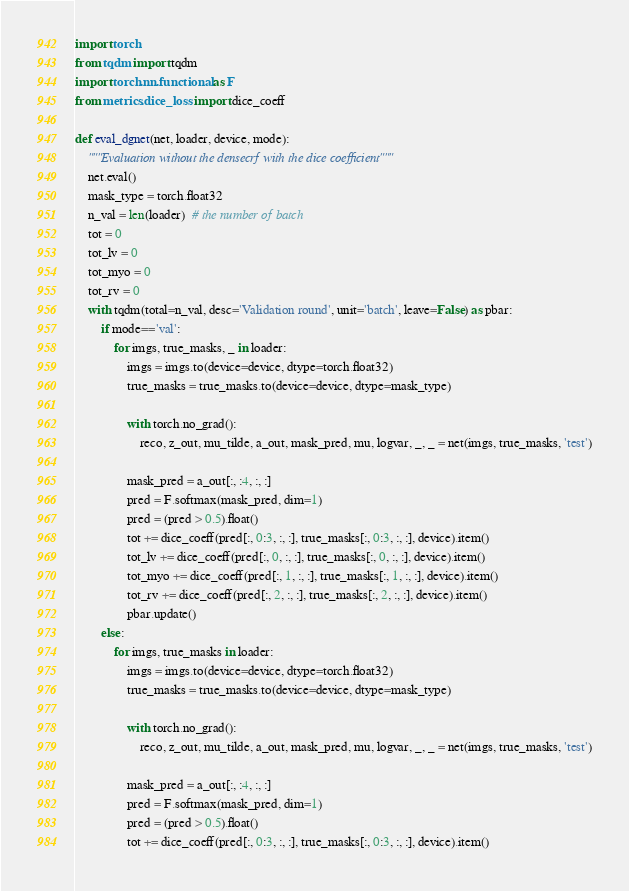Convert code to text. <code><loc_0><loc_0><loc_500><loc_500><_Python_>import torch
from tqdm import tqdm
import torch.nn.functional as F
from metrics.dice_loss import dice_coeff

def eval_dgnet(net, loader, device, mode):
    """Evaluation without the densecrf with the dice coefficient"""
    net.eval()
    mask_type = torch.float32
    n_val = len(loader)  # the number of batch
    tot = 0
    tot_lv = 0
    tot_myo = 0
    tot_rv = 0
    with tqdm(total=n_val, desc='Validation round', unit='batch', leave=False) as pbar:
        if mode=='val':
            for imgs, true_masks, _ in loader:
                imgs = imgs.to(device=device, dtype=torch.float32)
                true_masks = true_masks.to(device=device, dtype=mask_type)

                with torch.no_grad():
                    reco, z_out, mu_tilde, a_out, mask_pred, mu, logvar, _, _ = net(imgs, true_masks, 'test')

                mask_pred = a_out[:, :4, :, :]
                pred = F.softmax(mask_pred, dim=1)
                pred = (pred > 0.5).float()
                tot += dice_coeff(pred[:, 0:3, :, :], true_masks[:, 0:3, :, :], device).item()
                tot_lv += dice_coeff(pred[:, 0, :, :], true_masks[:, 0, :, :], device).item()
                tot_myo += dice_coeff(pred[:, 1, :, :], true_masks[:, 1, :, :], device).item()
                tot_rv += dice_coeff(pred[:, 2, :, :], true_masks[:, 2, :, :], device).item()
                pbar.update()
        else:
            for imgs, true_masks in loader:
                imgs = imgs.to(device=device, dtype=torch.float32)
                true_masks = true_masks.to(device=device, dtype=mask_type)

                with torch.no_grad():
                    reco, z_out, mu_tilde, a_out, mask_pred, mu, logvar, _, _ = net(imgs, true_masks, 'test')

                mask_pred = a_out[:, :4, :, :]
                pred = F.softmax(mask_pred, dim=1)
                pred = (pred > 0.5).float()
                tot += dice_coeff(pred[:, 0:3, :, :], true_masks[:, 0:3, :, :], device).item()</code> 